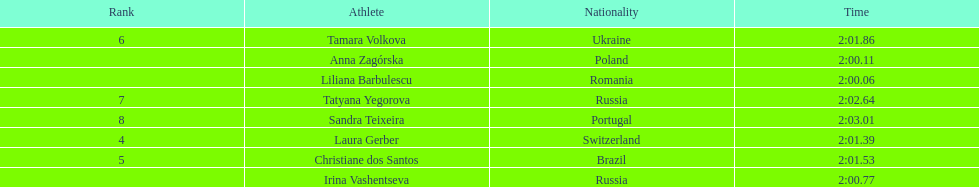The last runner crossed the finish line in 2:03.01. what was the previous time for the 7th runner? 2:02.64. Give me the full table as a dictionary. {'header': ['Rank', 'Athlete', 'Nationality', 'Time'], 'rows': [['6', 'Tamara Volkova', 'Ukraine', '2:01.86'], ['', 'Anna Zagórska', 'Poland', '2:00.11'], ['', 'Liliana Barbulescu', 'Romania', '2:00.06'], ['7', 'Tatyana Yegorova', 'Russia', '2:02.64'], ['8', 'Sandra Teixeira', 'Portugal', '2:03.01'], ['4', 'Laura Gerber', 'Switzerland', '2:01.39'], ['5', 'Christiane dos Santos', 'Brazil', '2:01.53'], ['', 'Irina Vashentseva', 'Russia', '2:00.77']]} 